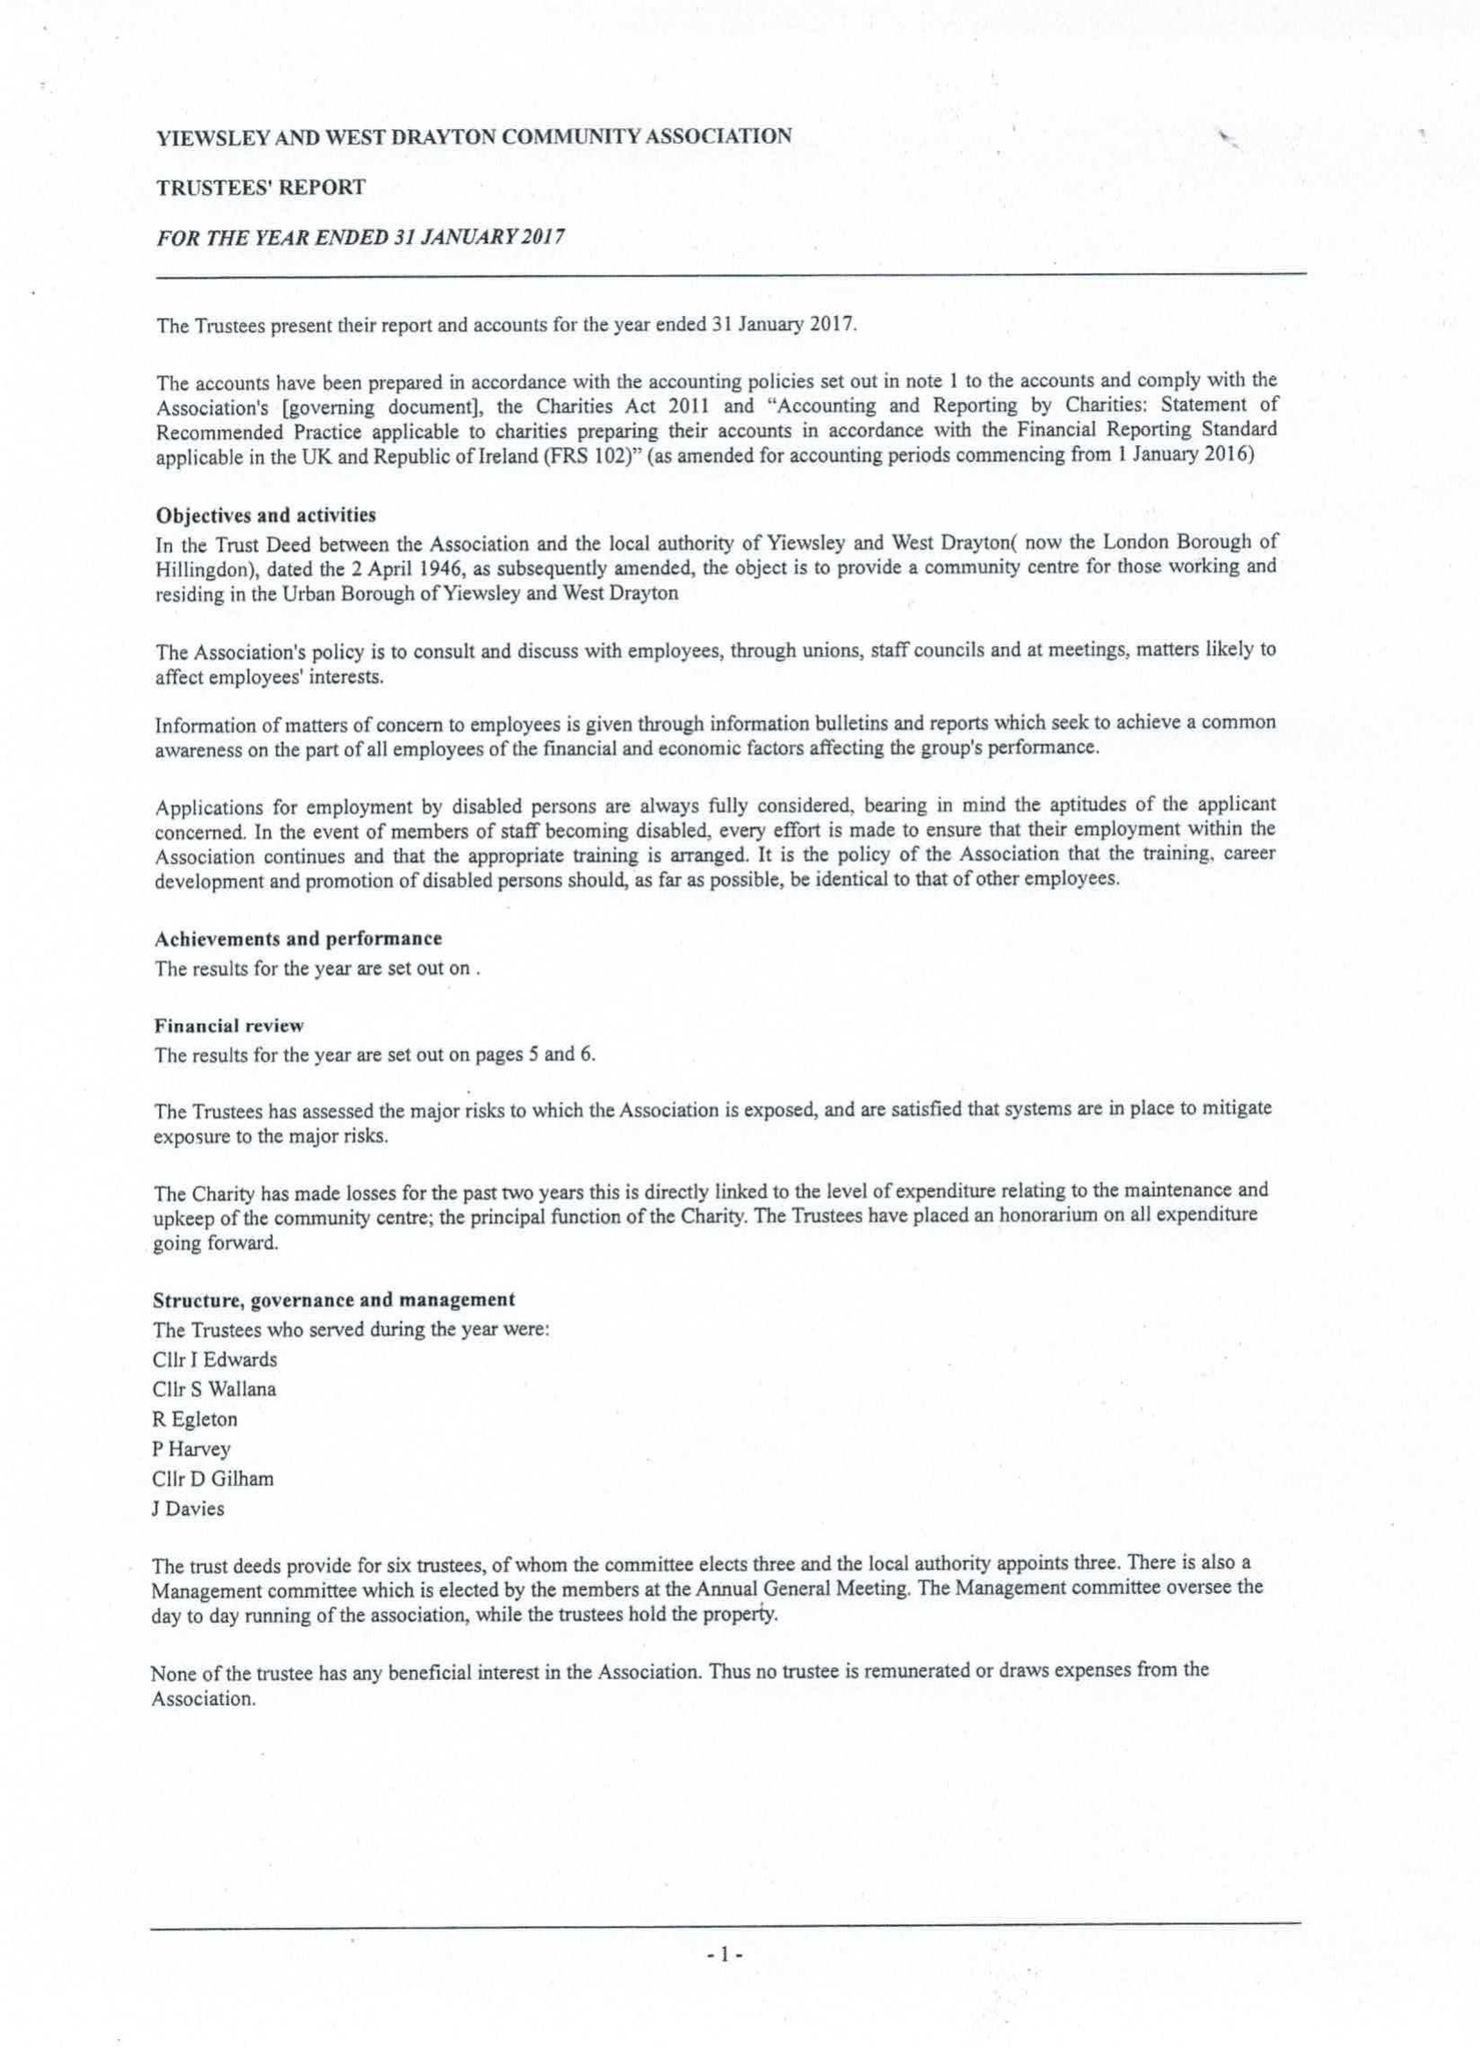What is the value for the spending_annually_in_british_pounds?
Answer the question using a single word or phrase. 160306.00 